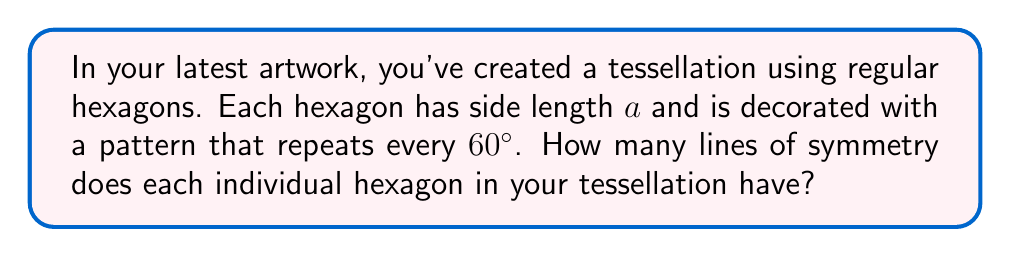Could you help me with this problem? Let's approach this step-by-step:

1) First, recall that a regular hexagon has 6 equal sides and 6 equal angles, each measuring 120°.

2) Lines of symmetry in a regular polygon pass through the center and either:
   a) Connect opposite vertices, or
   b) Bisect opposite sides

3) For a regular hexagon:
   - There are 3 lines connecting opposite vertices
   - There are 3 lines bisecting opposite sides

4) Therefore, a regular hexagon typically has 6 lines of symmetry.

5) However, the question mentions that the pattern within each hexagon repeats every 60°. This is a key detail.

6) 60° is exactly half of the 120° internal angle of a regular hexagon. This means the pattern aligns with the hexagon's inherent symmetry.

7) The 60° rotational symmetry of the pattern coincides with the 6-fold rotational symmetry of the hexagon.

8) As a result, all 6 lines of symmetry of the hexagon are preserved by the pattern.

Therefore, each individual hexagon in your tessellation maintains all 6 lines of symmetry.

[asy]
unitsize(1cm);
pair A=(1,0), B=(0.5,sqrt(3)/2), C=(-0.5,sqrt(3)/2), D=(-1,0), E=(-0.5,-sqrt(3)/2), F=(0.5,-sqrt(3)/2);
draw(A--B--C--D--E--F--cycle);
draw(A--D);
draw(B--E);
draw(C--F);
draw((0,1)--(0,-1));
draw((sqrt(3)/2,0.5)--(-sqrt(3)/2,-0.5));
draw((sqrt(3)/2,-0.5)--(-sqrt(3)/2,0.5));
[/asy]
Answer: 6 